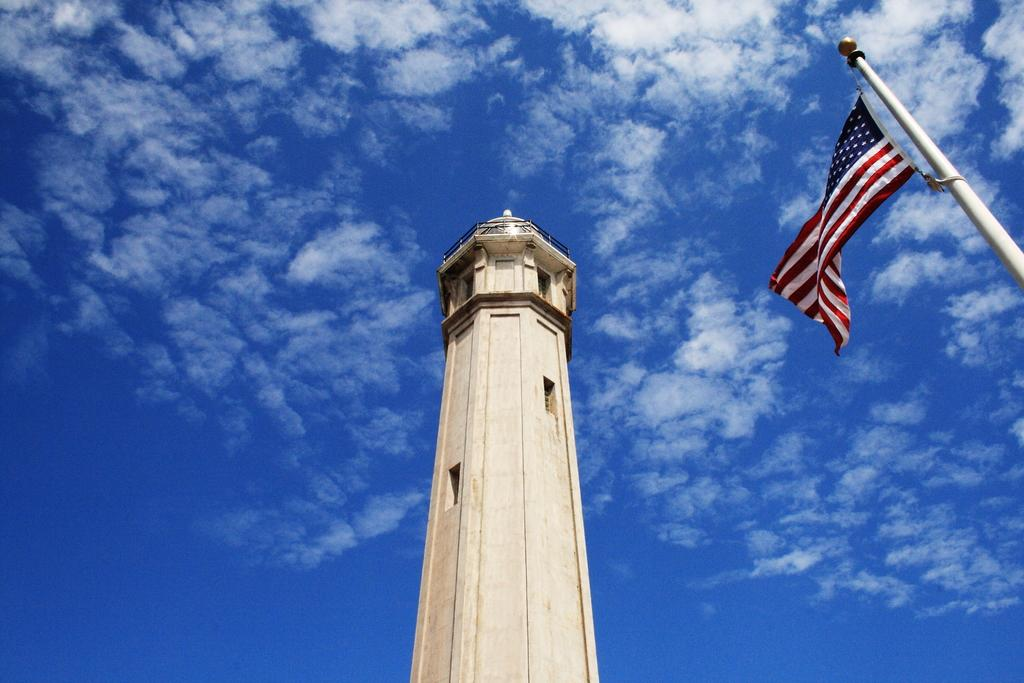What structure is located in the middle of the image? There is a tower in the middle of the image. What can be seen on the right side of the image? There is a flag on the right side of the image. What is visible at the top of the image? The sky is visible at the top of the image. What can be observed in the sky? Clouds are present in the sky. Can you tell me what the woman is writing with in the image? There is no woman present in the image. What does the father say about the tower in the image? There is no father or dialogue present in the image. 